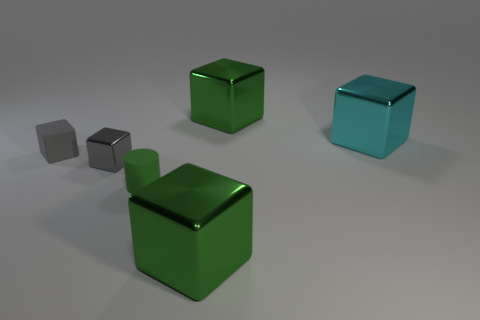Subtract 1 cubes. How many cubes are left? 4 Subtract all cyan cubes. How many cubes are left? 4 Subtract all red blocks. Subtract all purple balls. How many blocks are left? 5 Add 3 tiny green objects. How many objects exist? 9 Subtract all cylinders. How many objects are left? 5 Subtract 0 red spheres. How many objects are left? 6 Subtract all big cyan metal cubes. Subtract all gray shiny cubes. How many objects are left? 4 Add 2 cyan things. How many cyan things are left? 3 Add 4 cyan spheres. How many cyan spheres exist? 4 